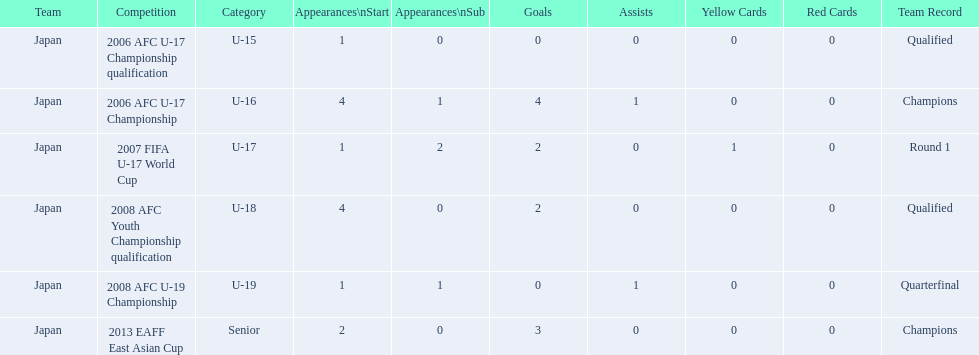How many total goals were scored? 11. Would you be able to parse every entry in this table? {'header': ['Team', 'Competition', 'Category', 'Appearances\\nStart', 'Appearances\\nSub', 'Goals', 'Assists', 'Yellow Cards', 'Red Cards', 'Team Record'], 'rows': [['Japan', '2006 AFC U-17 Championship qualification', 'U-15', '1', '0', '0', '0', '0', '0', 'Qualified'], ['Japan', '2006 AFC U-17 Championship', 'U-16', '4', '1', '4', '1', '0', '0', 'Champions'], ['Japan', '2007 FIFA U-17 World Cup', 'U-17', '1', '2', '2', '0', '1', '0', 'Round 1'], ['Japan', '2008 AFC Youth Championship qualification', 'U-18', '4', '0', '2', '0', '0', '0', 'Qualified'], ['Japan', '2008 AFC U-19 Championship', 'U-19', '1', '1', '0', '1', '0', '0', 'Quarterfinal'], ['Japan', '2013 EAFF East Asian Cup', 'Senior', '2', '0', '3', '0', '0', '0', 'Champions']]} 